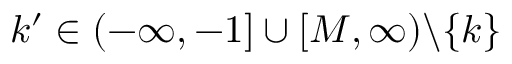Convert formula to latex. <formula><loc_0><loc_0><loc_500><loc_500>k ^ { \prime } \in ( - \infty , - 1 ] \cup [ M , \infty ) \ \{ k \}</formula> 